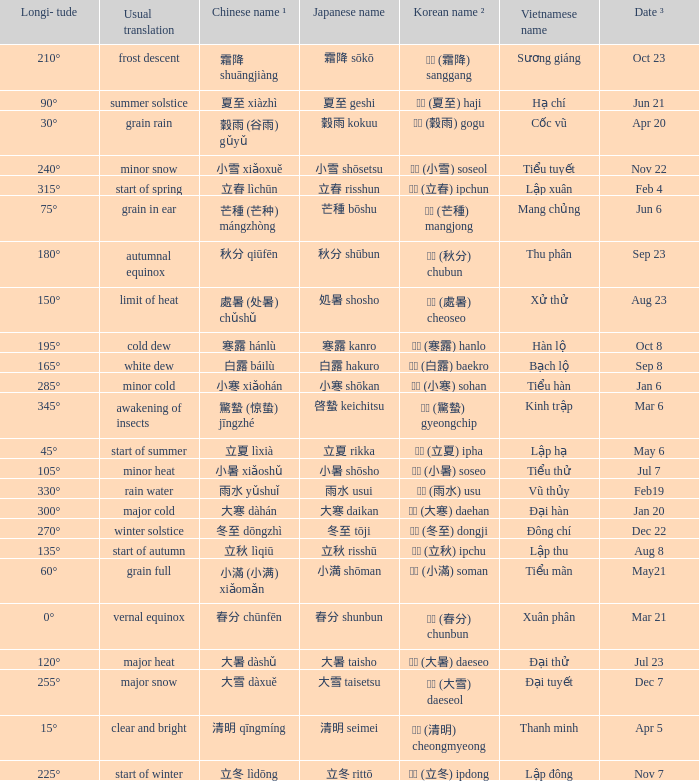Which Japanese name has a Korean name ² of 경칩 (驚蟄) gyeongchip? 啓蟄 keichitsu. 